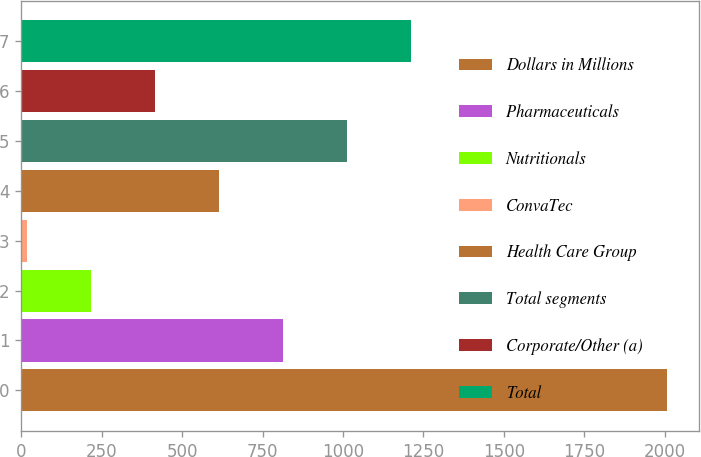Convert chart. <chart><loc_0><loc_0><loc_500><loc_500><bar_chart><fcel>Dollars in Millions<fcel>Pharmaceuticals<fcel>Nutritionals<fcel>ConvaTec<fcel>Health Care Group<fcel>Total segments<fcel>Corporate/Other (a)<fcel>Total<nl><fcel>2006<fcel>813.2<fcel>216.8<fcel>18<fcel>614.4<fcel>1012<fcel>415.6<fcel>1210.8<nl></chart> 